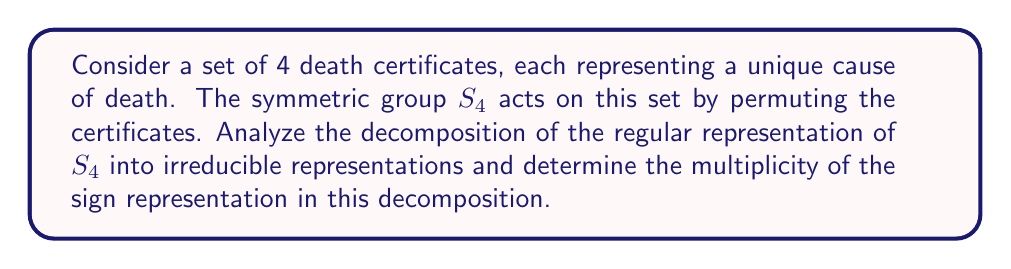Help me with this question. Let's approach this step-by-step:

1) The regular representation of $S_4$ has dimension $|S_4| = 4! = 24$.

2) The irreducible representations of $S_4$ correspond to partitions of 4:
   - [4]: trivial representation, dimension 1
   - [3,1]: standard representation, dimension 3
   - [2,2]: dimension 2
   - [2,1,1]: dimension 3
   - [1,1,1,1]: sign representation, dimension 1

3) Let's call these representations $\chi_1, \chi_2, \chi_3, \chi_4, \chi_5$ respectively.

4) The regular representation decomposes as:
   $R = \sum_{i=1}^5 (\dim \chi_i) \chi_i$

5) This means:
   $R = 1\chi_1 + 3\chi_2 + 2\chi_3 + 3\chi_4 + 1\chi_5$

6) We can verify: $1^2 + 3^2 + 2^2 + 3^2 + 1^2 = 24$, which is the dimension of R.

7) The sign representation $\chi_5$ appears with multiplicity 1 in this decomposition.
Answer: 1 